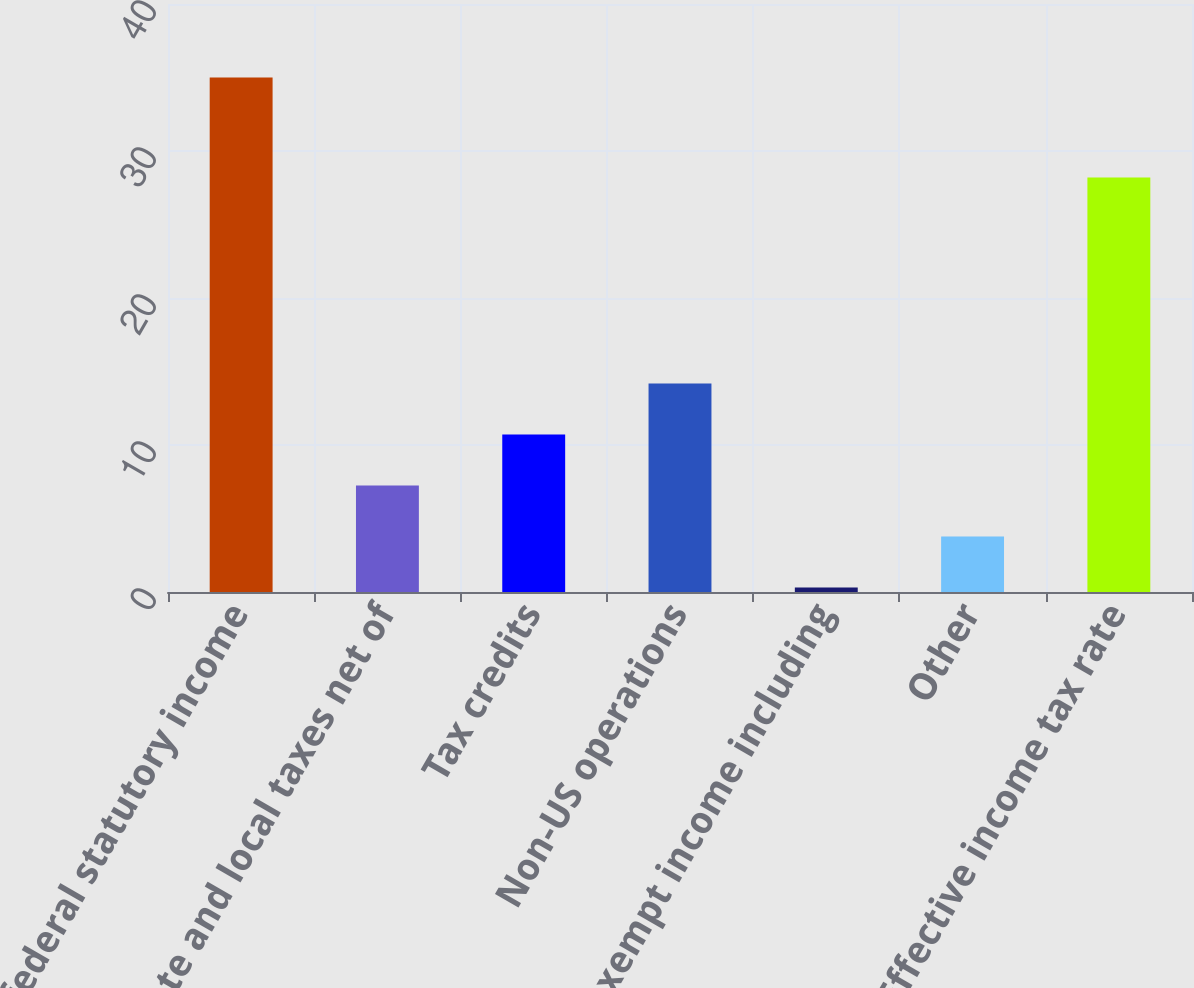<chart> <loc_0><loc_0><loc_500><loc_500><bar_chart><fcel>US federal statutory income<fcel>State and local taxes net of<fcel>Tax credits<fcel>Non-US operations<fcel>Tax-exempt income including<fcel>Other<fcel>Effective income tax rate<nl><fcel>35<fcel>7.24<fcel>10.71<fcel>14.18<fcel>0.3<fcel>3.77<fcel>28.2<nl></chart> 